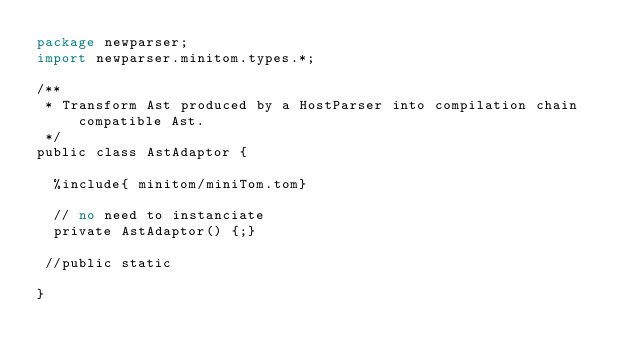<code> <loc_0><loc_0><loc_500><loc_500><_Perl_>package newparser;
import newparser.minitom.types.*;

/**
 * Transform Ast produced by a HostParser into compilation chain compatible Ast.
 */
public class AstAdaptor {

  %include{ minitom/miniTom.tom}

  // no need to instanciate
  private AstAdaptor() {;}

 //public static 

}
</code> 